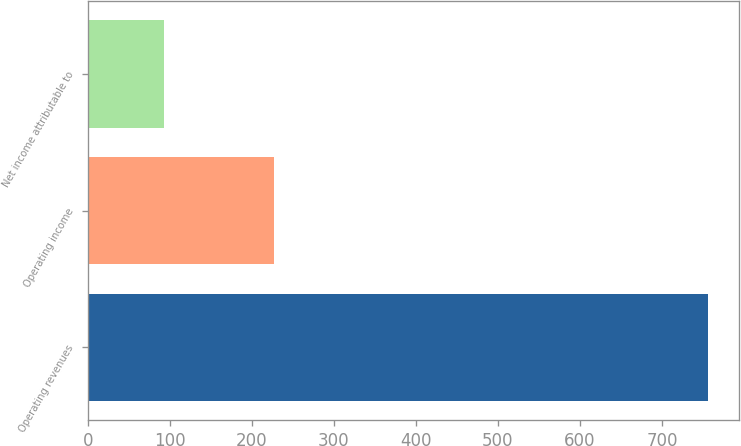<chart> <loc_0><loc_0><loc_500><loc_500><bar_chart><fcel>Operating revenues<fcel>Operating income<fcel>Net income attributable to<nl><fcel>756<fcel>227<fcel>93<nl></chart> 